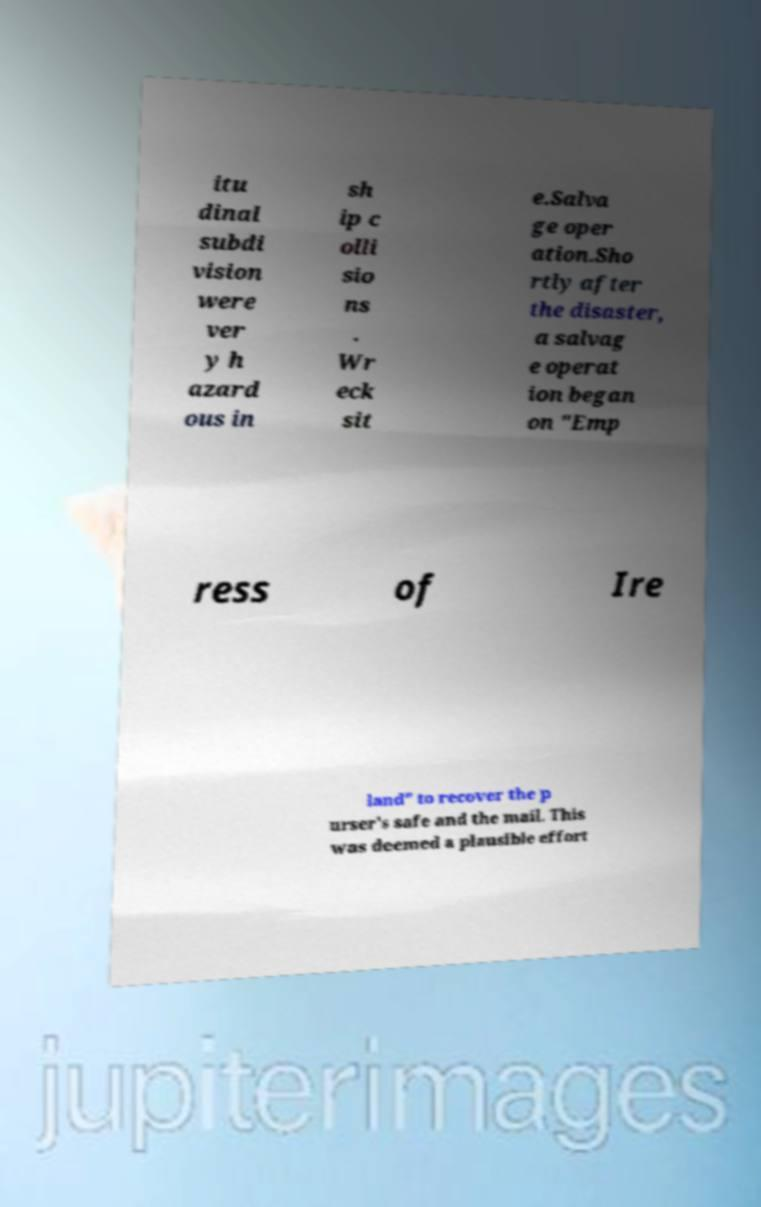What messages or text are displayed in this image? I need them in a readable, typed format. itu dinal subdi vision were ver y h azard ous in sh ip c olli sio ns . Wr eck sit e.Salva ge oper ation.Sho rtly after the disaster, a salvag e operat ion began on "Emp ress of Ire land" to recover the p urser's safe and the mail. This was deemed a plausible effort 